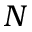Convert formula to latex. <formula><loc_0><loc_0><loc_500><loc_500>N</formula> 